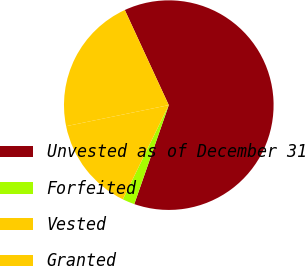<chart> <loc_0><loc_0><loc_500><loc_500><pie_chart><fcel>Unvested as of December 31<fcel>Forfeited<fcel>Vested<fcel>Granted<nl><fcel>62.24%<fcel>1.88%<fcel>14.56%<fcel>21.33%<nl></chart> 